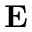Convert formula to latex. <formula><loc_0><loc_0><loc_500><loc_500>E</formula> 